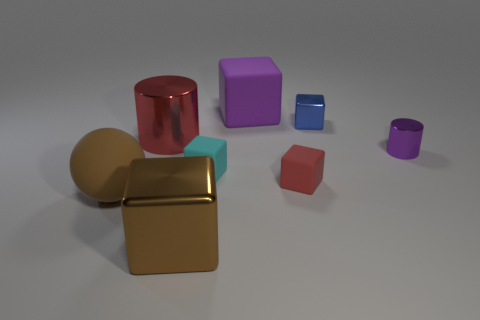Subtract all big purple cubes. How many cubes are left? 4 Add 1 cyan blocks. How many objects exist? 9 Subtract all red blocks. How many blocks are left? 4 Subtract 1 blocks. How many blocks are left? 4 Subtract all blocks. How many objects are left? 3 Subtract all gray blocks. Subtract all purple spheres. How many blocks are left? 5 Subtract all red cylinders. Subtract all small blocks. How many objects are left? 4 Add 2 small matte things. How many small matte things are left? 4 Add 7 small purple metallic cylinders. How many small purple metallic cylinders exist? 8 Subtract 1 blue cubes. How many objects are left? 7 